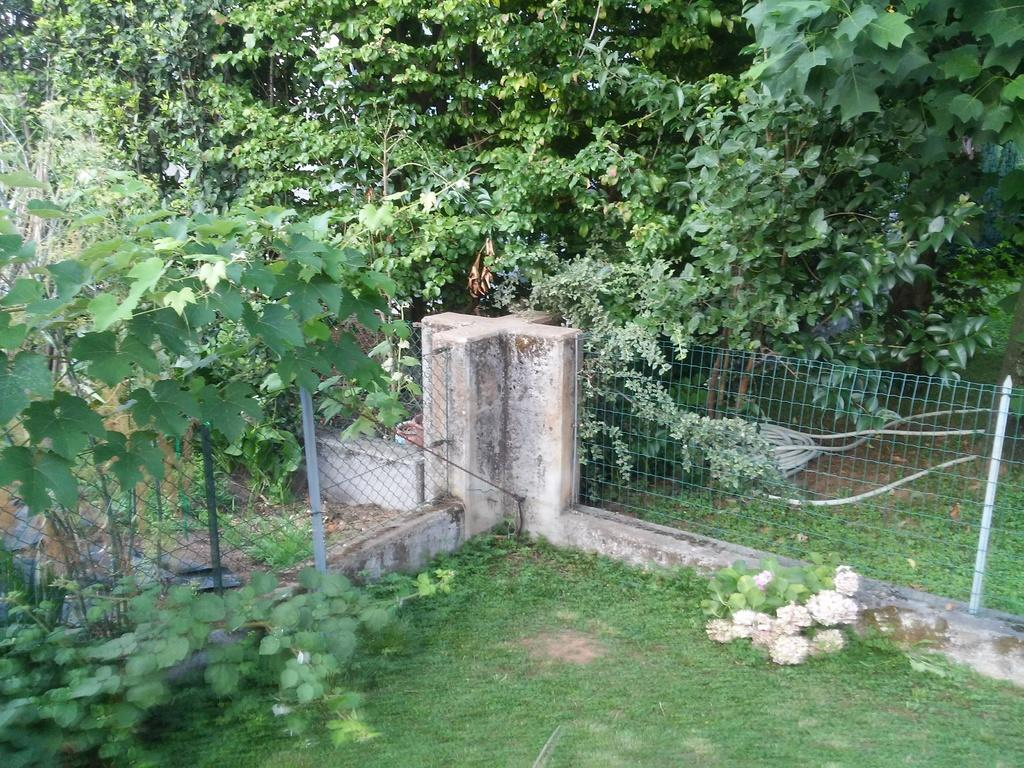What type of vegetation can be seen in the image? There are trees and plants in the image. What type of barrier is present in the image? There are fences in the image. What type of ground cover is visible in the image? There is grass in the image. What man-made object can be seen in the image? There is a pipe in the image. Can you hear the thunder in the image? There is no sound present in the image, so it is not possible to hear thunder. 